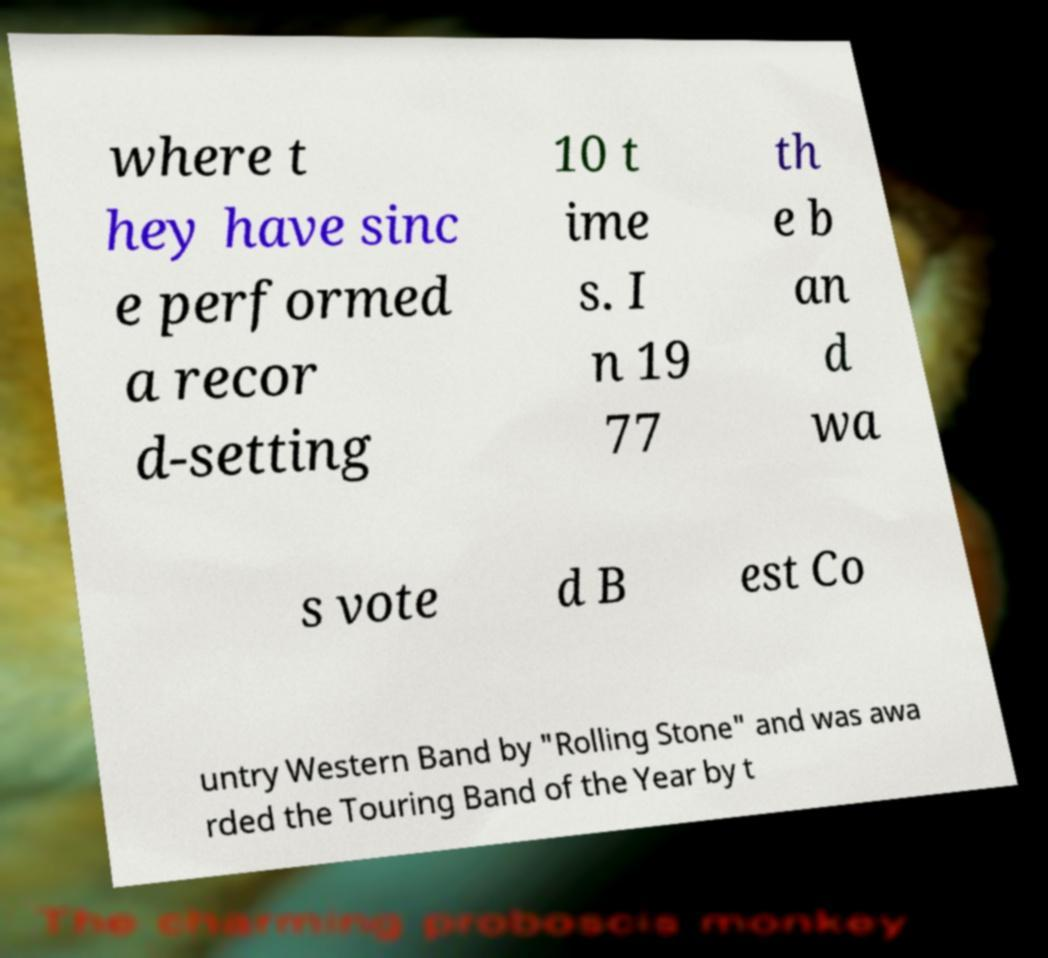Can you read and provide the text displayed in the image?This photo seems to have some interesting text. Can you extract and type it out for me? where t hey have sinc e performed a recor d-setting 10 t ime s. I n 19 77 th e b an d wa s vote d B est Co untry Western Band by "Rolling Stone" and was awa rded the Touring Band of the Year by t 